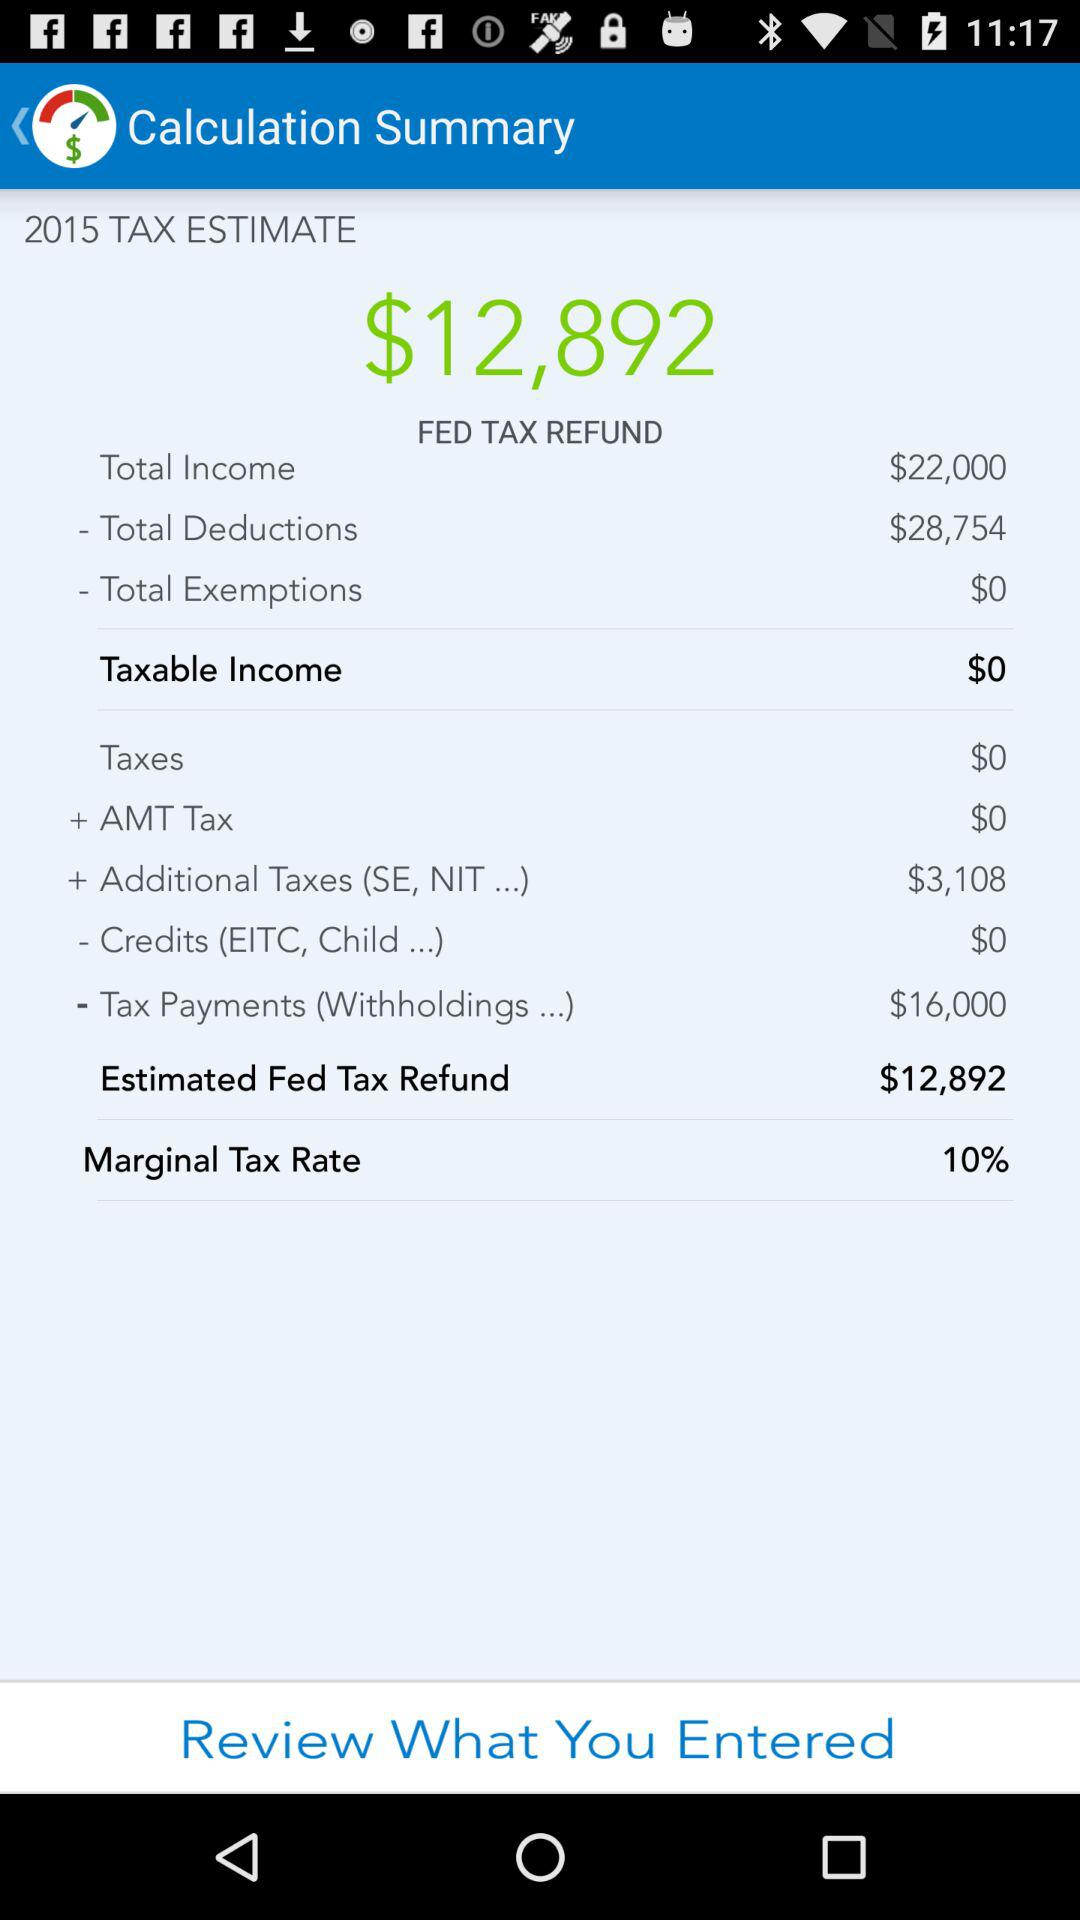What is the marginal tax rate? The marginal tax rate is 10%. 